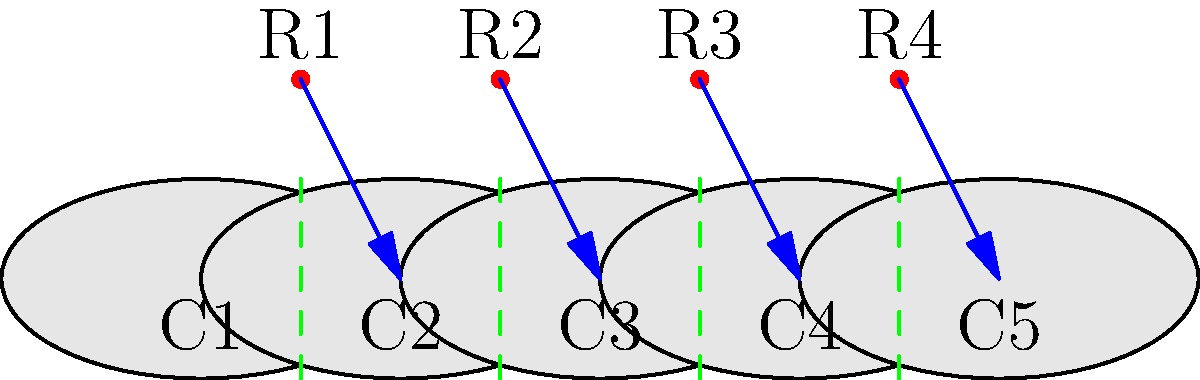In the diagram above, refugee camps (R1-R4) are shown between countries (C1-C5). The arrows represent primary migration patterns, and the dashed green lines indicate border regions. Which topological property best describes the relationship between refugee camps and border regions, and how might this impact human rights considerations in these areas? To answer this question, let's analyze the topological features of the diagram step-by-step:

1. Spatial arrangement: The refugee camps (R1-R4) are positioned between the countries (C1-C5).

2. Connectivity: Each refugee camp is connected to a country via an arrow, representing primary migration patterns.

3. Border regions: The dashed green lines represent border regions between adjacent countries.

4. Topological property: The key topological property here is the notion of "betweenness." The refugee camps are situated between countries and near border regions.

5. Impact on human rights:
   a) Accessibility: Refugee camps' proximity to borders may affect access to humanitarian aid and services.
   b) Legal status: Being near borders can complicate the legal status of refugees and their rights.
   c) Security: Border regions may face increased security measures, potentially limiting refugees' freedom of movement.
   d) Resource allocation: The distribution of resources and aid may be influenced by the camps' locations relative to borders.

6. Challenging beliefs: This arrangement challenges the notion of clear-cut national boundaries and highlights the complex realities of refugee experiences.

The topological property of "betweenness" in this context emphasizes the liminal nature of refugee camps and their inhabitants, existing in spaces that are neither fully within nor outside of national territories. This spatial arrangement has significant implications for human rights considerations, as it can lead to ambiguities in legal protections, access to resources, and the overall treatment of refugees.
Answer: Betweenness; impacts legal status, security, and resource allocation in border regions. 